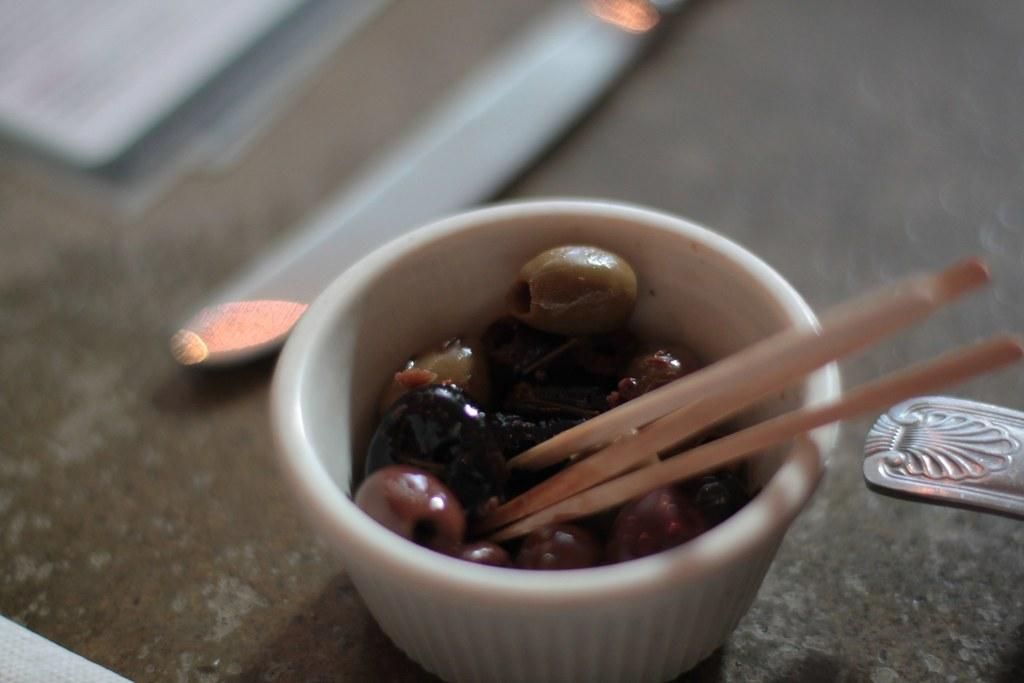What is in the image that can hold food? There is a bowl in the image that can hold food. What type of food is in the bowl? The bowl contains food, but the specific type of food is not mentioned in the facts. What utensils or objects are present in the image? There are toothpicks in the image. Is there a monkey in the image using the toothpicks to escape from jail? No, there is no monkey or jail present in the image. The image only contains a bowl with food and toothpicks. 